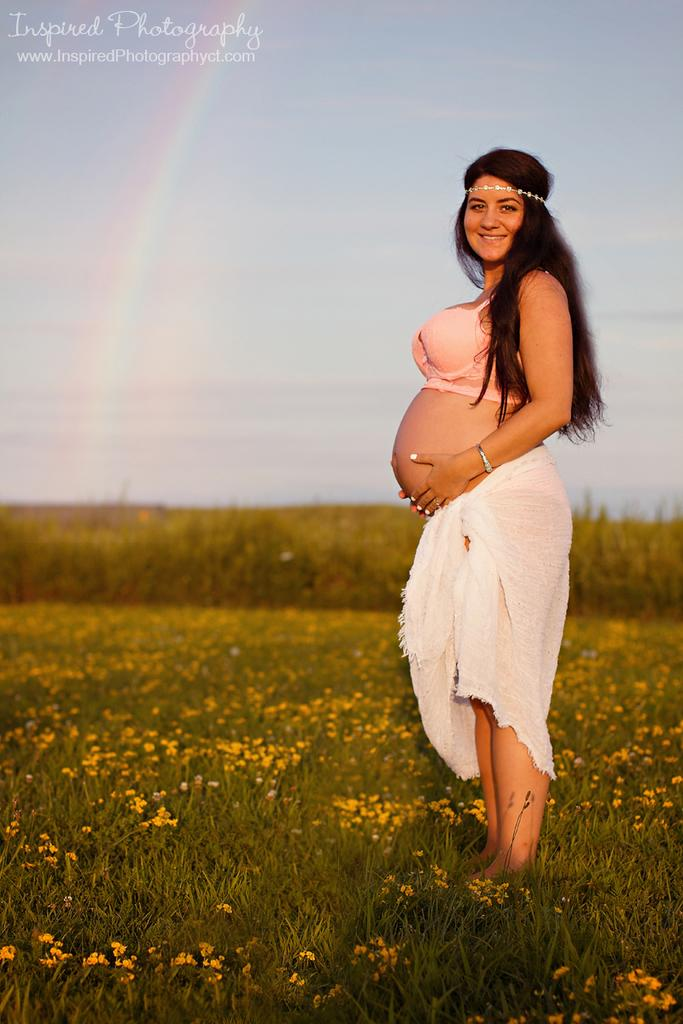What is the main subject of the image? There is a woman standing in the image. Can you describe the woman's attire? The woman is wearing a white and peach color dress. What type of flowers can be seen in the image? There are yellow color flowers in the image. What is the color of the grass in the image? There is green grass in the image. How would you describe the sky in the image? The sky is blue and white in color. Where are the shoes placed in the image? There are no shoes visible in the image. Can you see any fairies flying around the woman in the image? There are no fairies present in the image. 